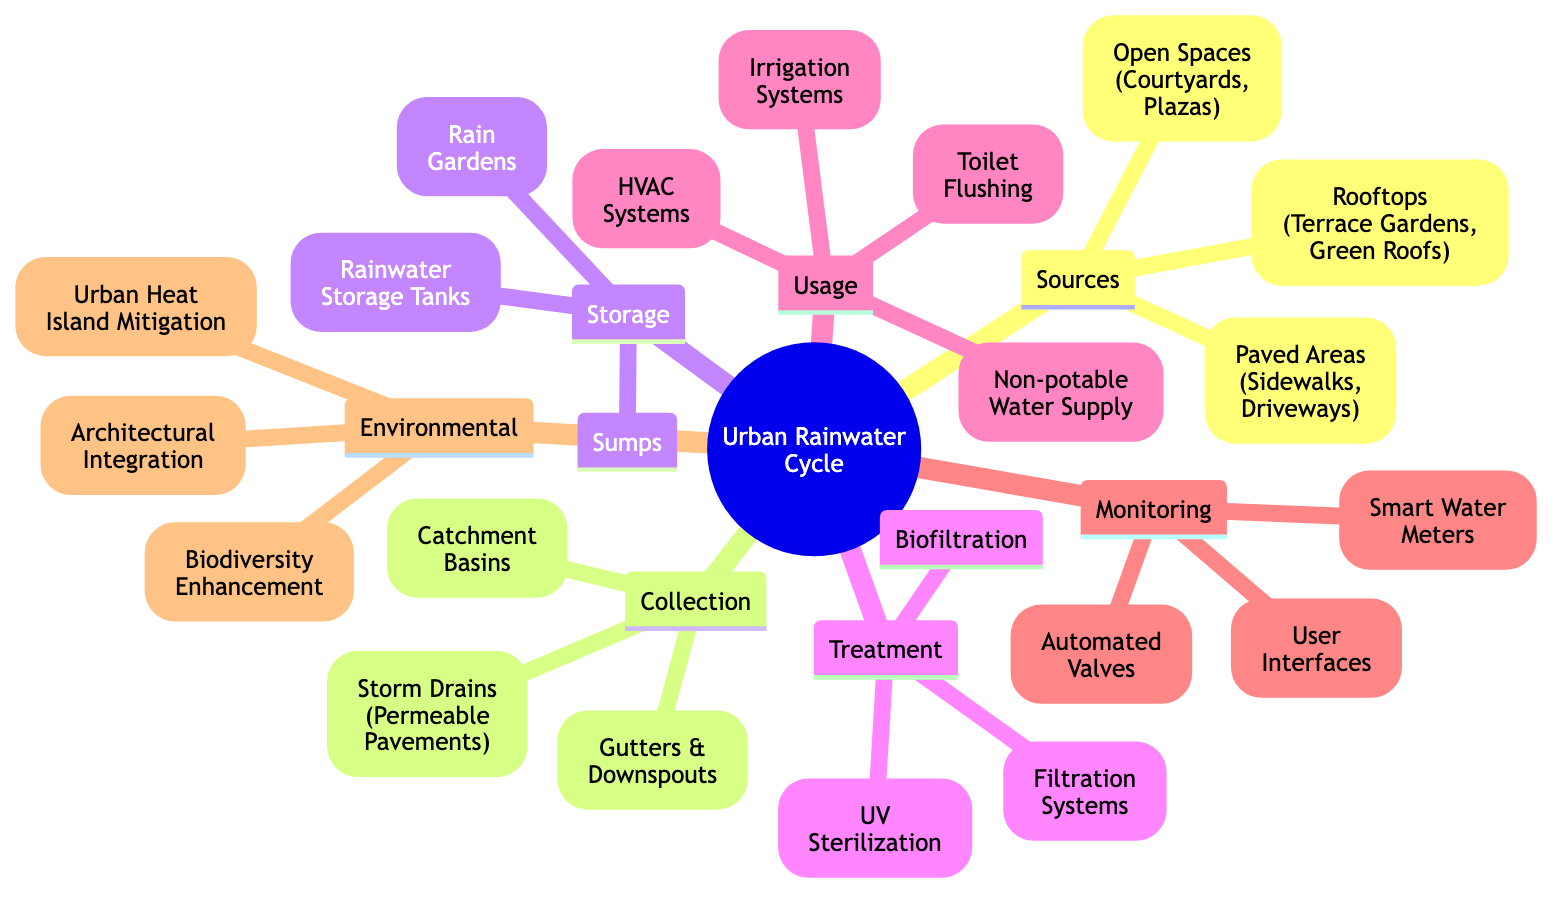What are three sources of rainwater in an urban environment? The diagram lists three sources: Rooftops (including terrace gardens and green roofs), paved areas (such as sidewalks and driveways), and open spaces (like courtyards and plazas). These provide the initial collection points for rainwater in urban settings.
Answer: Rooftops, paved areas, open spaces How many methods of rainwater collection are listed? There are three methods of rainwater collection mentioned in the diagram: gutters & downspouts, storm drains (which include permeable pavements), and catchment basins. This indicates the various infrastructures that can gather rainwater.
Answer: 3 Name two types of storage systems for rainwater shown in the diagram. The storage section of the diagram indicates that rainwater can be stored in rainwater storage tanks and sumps, and also mentions rain gardens. These are important for holding collected rainwater before use.
Answer: Rainwater storage tanks, sumps Which treatment method uses ultraviolet light? UV sterilization is a treatment method listed in the diagram, specifically indicating that it employs ultraviolet light to treat collected rainwater, ensuring it is safe for use.
Answer: UV sterilization What is one usage for treated rainwater in buildings? The diagram lists several uses for treated rainwater, one of which includes irrigation systems, where the water is utilized for landscaping or gardening in urban settings.
Answer: Irrigation systems How do environmental benefits relate to rainwater harvesting in urban architecture? The diagram connects environmental benefits such as urban heat island mitigation, biodiversity enhancement, and architectural integration to the broader context of using rainwater harvesting. This suggests that rainwater harvesting contributes positively to urban ecosystems.
Answer: Urban heat island mitigation, biodiversity enhancement, architectural integration How many monitoring technologies are mentioned? The diagram illustrates three monitoring technologies for rainwater systems: smart water meters, automated valves, and user interfaces, indicating the importance of technology in managing rainwater harvesting effectively.
Answer: 3 Which part of the diagram includes collection methods? The collection methods are detailed under the 'Collection' section of the diagram, highlighting the various strategies employed to gather rainwater from different sources. This organization helps viewers understand the sequence of the rainwater cycle.
Answer: Collection What is the overarching theme of the diagram? The overarching theme of the diagram is the urban rainwater cycle, focusing on how rainwater can be harvested, treated, and utilized effectively in architecture, emphasizing sustainability in urban environments.
Answer: Urban Rainwater Cycle 